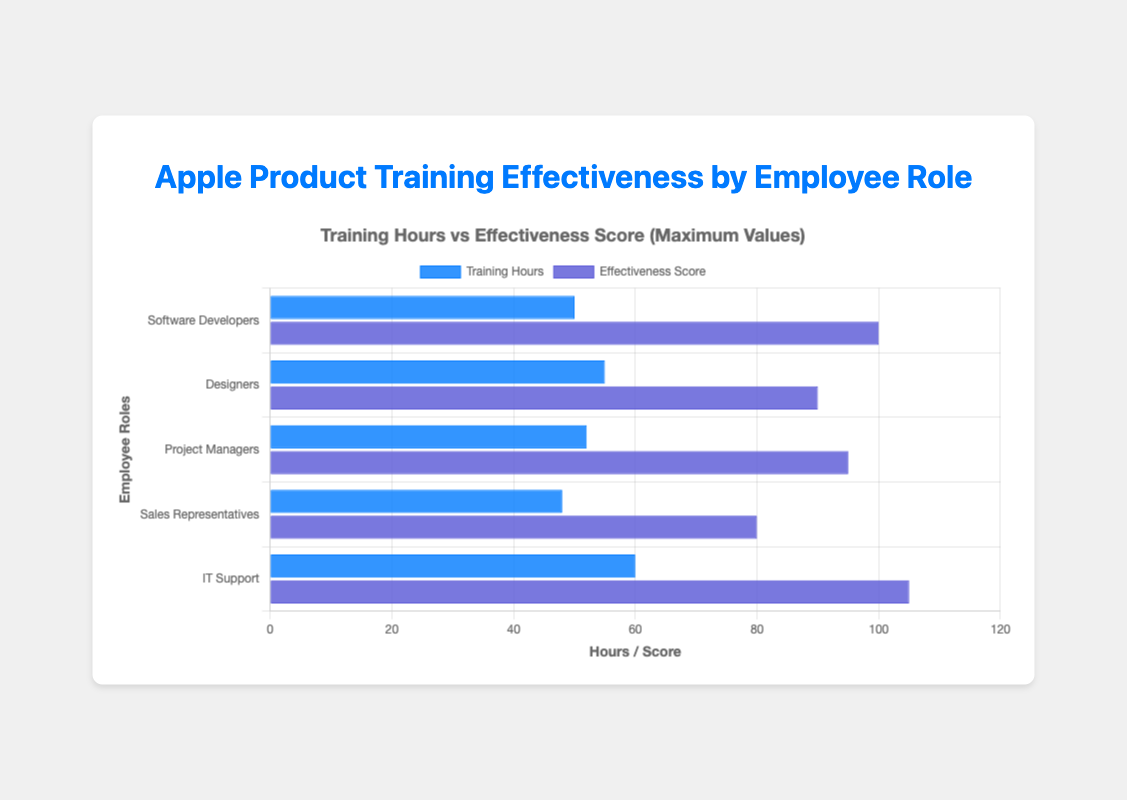What is the total number of Training Hours for IT Support? To find the total number of Training Hours for IT Support, add up the values: 20 + 30 + 40 + 50 + 60. This equals 200 hours.
Answer: 200 Which employee role has the highest Effectiveness Score in the chart? Look at the highest blue bar in the chart, which represents the Effectiveness Score. IT Support has the highest score with 105.
Answer: IT Support How does the Training Hours for Project Managers compare to Designers? Check the lengths of the red bars representing Training Hours for both roles. For Project Managers, it's 52 hours, and for Designers, it's 55 hours. Designers have more Training Hours.
Answer: Designers have more hours What is the average Effectiveness Score for Sales Representatives? Add up the Effectiveness Scores: 60 + 65 + 70 + 75 + 80 and divide by 5. This equals 350/5, which results in an average of 70.
Answer: 70 What's the difference between the highest and lowest Training Hours values among all roles? Find the highest (60 for IT Support) and the lowest (8 for Sales Representatives) Training Hours values and subtract: 60 - 8 equals 52 hours.
Answer: 52 Are the Effectiveness Scores of Software Developers generally higher than those of Designers? Compare the values in the Effectiveness Scores for both roles. Software Developers have scores of 80, 85, 90, 95, and 100, while Designers have 70, 75, 80, 85, and 90. All Software Developers' scores are higher than Designers' scores.
Answer: Yes Which employee role has the lowest Training Hours? Refer to the shortest red bar. Sales Representatives have the lowest Training Hours at 48 hours.
Answer: Sales Representatives How much higher is the Effectiveness Score for IT Support compared to Project Managers? Look at the highest Effectiveness Scores for both roles: IT Support has 105 and Project Managers have 95. The difference is 105 - 95, which is 10 points.
Answer: 10 What is the Training Hours to Effectiveness Score ratio for Software Developers? For the maximum values, divide the Training Hours (50) by the Effectiveness Score (100). The ratio is 50/100, which simplifies to 1/2 or 0.5.
Answer: 0.5 Among the employee roles, who has the greatest increase in Effectiveness Score with increasing Training Hours? Review the trend of Effectiveness Scores with increasing Training Hours for all roles. IT Support goes from 85 to 105, an increase of 20 points, which is the largest among the roles.
Answer: IT Support 